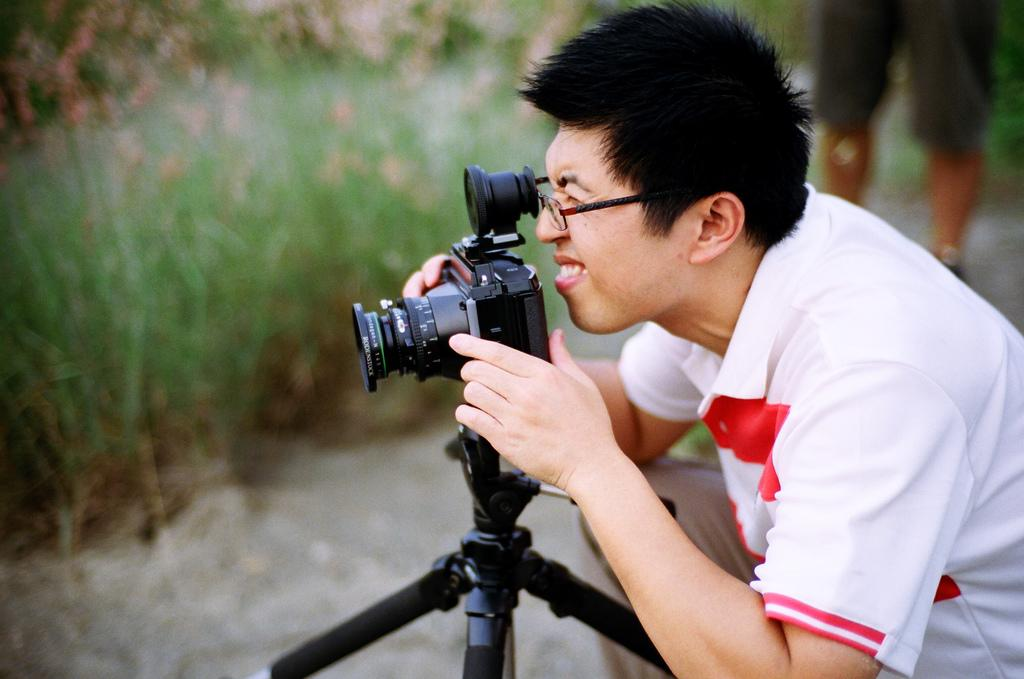How many people are present in the image? There are two people in the image. What is one of the people doing in the image? One of the people is holding a camera. What can be seen in the background of the image? There are plants in the background of the image. Can you describe the quality of the image? The image is blurry. What type of lipstick is the person wearing in the image? There is no person wearing lipstick in the image, as the focus is on the two people and the camera. 